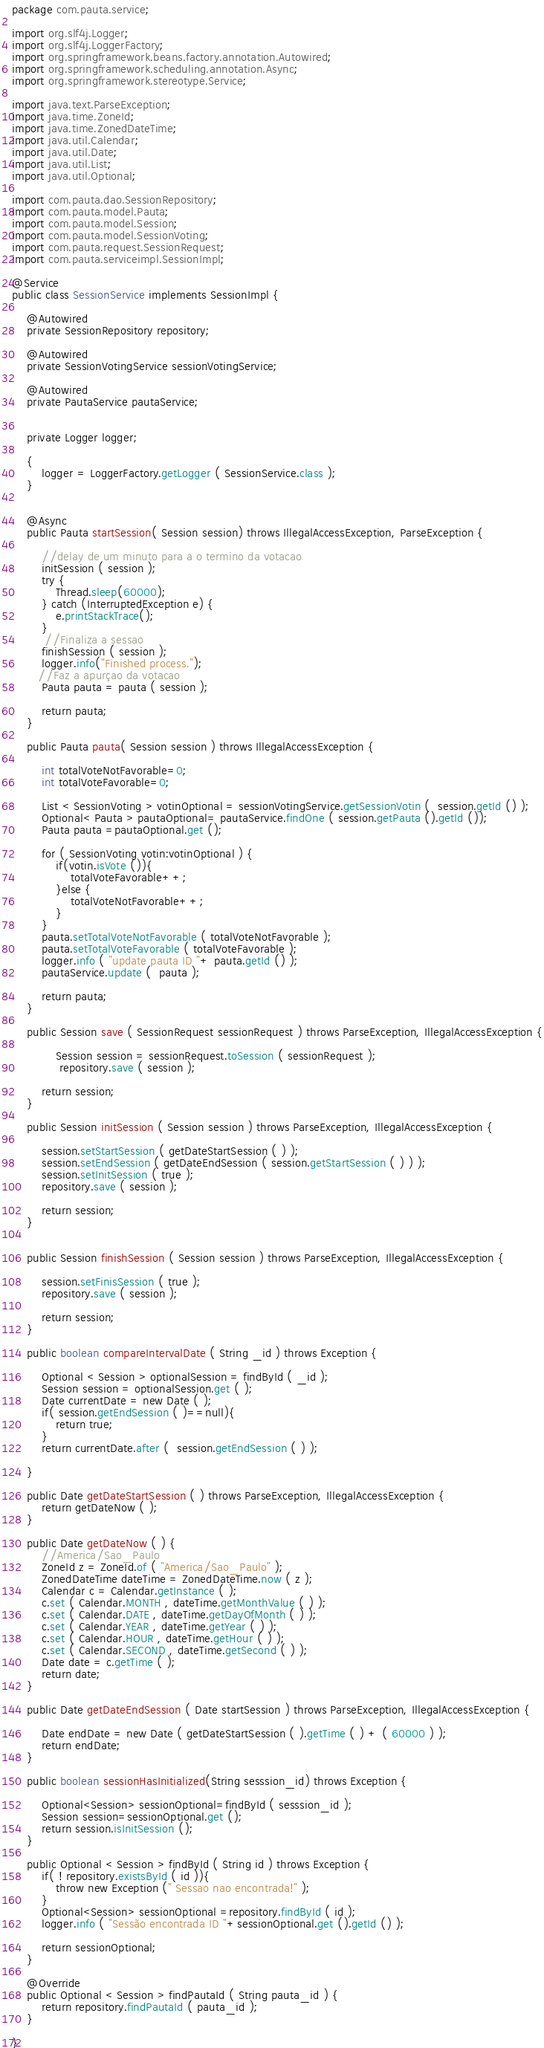Convert code to text. <code><loc_0><loc_0><loc_500><loc_500><_Java_>package com.pauta.service;

import org.slf4j.Logger;
import org.slf4j.LoggerFactory;
import org.springframework.beans.factory.annotation.Autowired;
import org.springframework.scheduling.annotation.Async;
import org.springframework.stereotype.Service;

import java.text.ParseException;
import java.time.ZoneId;
import java.time.ZonedDateTime;
import java.util.Calendar;
import java.util.Date;
import java.util.List;
import java.util.Optional;

import com.pauta.dao.SessionRepository;
import com.pauta.model.Pauta;
import com.pauta.model.Session;
import com.pauta.model.SessionVoting;
import com.pauta.request.SessionRequest;
import com.pauta.serviceimpl.SessionImpl;

@Service
public class SessionService implements SessionImpl {

    @Autowired
    private SessionRepository repository;

    @Autowired
    private SessionVotingService sessionVotingService;

    @Autowired
    private PautaService pautaService;


    private Logger logger;

    {
        logger = LoggerFactory.getLogger ( SessionService.class );
    }


    @Async
    public Pauta startSession( Session session) throws IllegalAccessException, ParseException {

        //delay de um minuto para a o termino da votacao
        initSession ( session );
        try {
            Thread.sleep(60000);
        } catch (InterruptedException e) {
            e.printStackTrace();
        }
         //Finaliza a sessao
        finishSession ( session );
        logger.info("Finished process.");
       //Faz a apurçao da votacao
        Pauta pauta = pauta ( session );

        return pauta;
    }

    public Pauta pauta( Session session ) throws IllegalAccessException {

        int totalVoteNotFavorable=0;
        int totalVoteFavorable=0;

        List < SessionVoting > votinOptional = sessionVotingService.getSessionVotin (  session.getId () );
        Optional< Pauta > pautaOptional= pautaService.findOne ( session.getPauta ().getId ());
        Pauta pauta =pautaOptional.get ();

        for ( SessionVoting votin:votinOptional ) {
            if(votin.isVote ()){
                totalVoteFavorable++;
            }else {
                totalVoteNotFavorable++;
            }
        }
        pauta.setTotalVoteNotFavorable ( totalVoteNotFavorable );
        pauta.setTotalVoteFavorable ( totalVoteFavorable );
        logger.info ( "update pauta ID "+ pauta.getId () );
        pautaService.update (  pauta );

        return pauta;
    }

    public Session save ( SessionRequest sessionRequest ) throws ParseException, IllegalAccessException {

            Session session = sessionRequest.toSession ( sessionRequest );
             repository.save ( session );

        return session;
    }

    public Session initSession ( Session session ) throws ParseException, IllegalAccessException {

        session.setStartSession ( getDateStartSession ( ) );
        session.setEndSession ( getDateEndSession ( session.getStartSession ( ) ) );
        session.setInitSession ( true );
        repository.save ( session );

        return session;
    }


    public Session finishSession ( Session session ) throws ParseException, IllegalAccessException {

        session.setFinisSession ( true );
        repository.save ( session );

        return session;
    }

    public boolean compareIntervalDate ( String _id ) throws Exception {

        Optional < Session > optionalSession = findById ( _id );
        Session session = optionalSession.get ( );
        Date currentDate = new Date ( );
        if( session.getEndSession ( )==null){
            return true;
        }
        return currentDate.after (  session.getEndSession ( ) );

    }

    public Date getDateStartSession ( ) throws ParseException, IllegalAccessException {
        return getDateNow ( );
    }

    public Date getDateNow ( ) {
        //America/Sao_Paulo
        ZoneId z = ZoneId.of ( "America/Sao_Paulo" );
        ZonedDateTime dateTime = ZonedDateTime.now ( z );
        Calendar c = Calendar.getInstance ( );
        c.set ( Calendar.MONTH , dateTime.getMonthValue ( ) );
        c.set ( Calendar.DATE , dateTime.getDayOfMonth ( ) );
        c.set ( Calendar.YEAR , dateTime.getYear ( ) );
        c.set ( Calendar.HOUR , dateTime.getHour ( ) );
        c.set ( Calendar.SECOND , dateTime.getSecond ( ) );
        Date date = c.getTime ( );
        return date;
    }

    public Date getDateEndSession ( Date startSession ) throws ParseException, IllegalAccessException {

        Date endDate = new Date ( getDateStartSession ( ).getTime ( ) + ( 60000 ) );
        return endDate;
    }

    public boolean sessionHasInitialized(String sesssion_id) throws Exception {

        Optional<Session> sessionOptional=findById ( sesssion_id );
        Session session=sessionOptional.get ();
        return session.isInitSession ();
    }

    public Optional < Session > findById ( String id ) throws Exception {
        if( ! repository.existsById ( id )){
            throw new Exception (" Sessao nao encontrada!" );
        }
        Optional<Session> sessionOptional =repository.findById ( id );
        logger.info ( "Sessão encontrada ID "+sessionOptional.get ().getId () );

        return sessionOptional;
    }

    @Override
    public Optional < Session > findPautaId ( String pauta_id ) {
        return repository.findPautaId ( pauta_id );
    }

}
</code> 